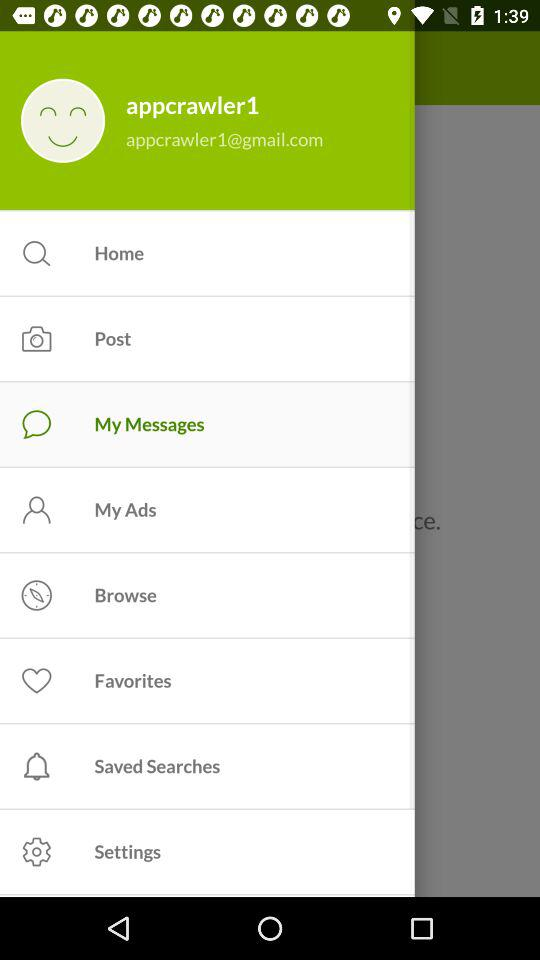What Gmail address is used? The used Gmail address is appcrawler1@gmail.com. 